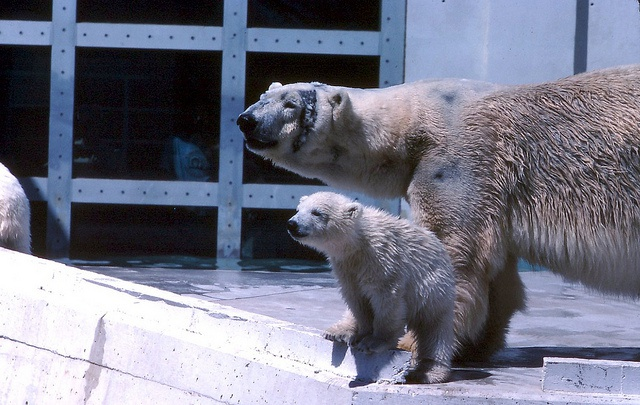Describe the objects in this image and their specific colors. I can see bear in black, gray, and darkgray tones, bear in black, gray, and darkgray tones, and bear in black, lavender, gray, and darkgray tones in this image. 